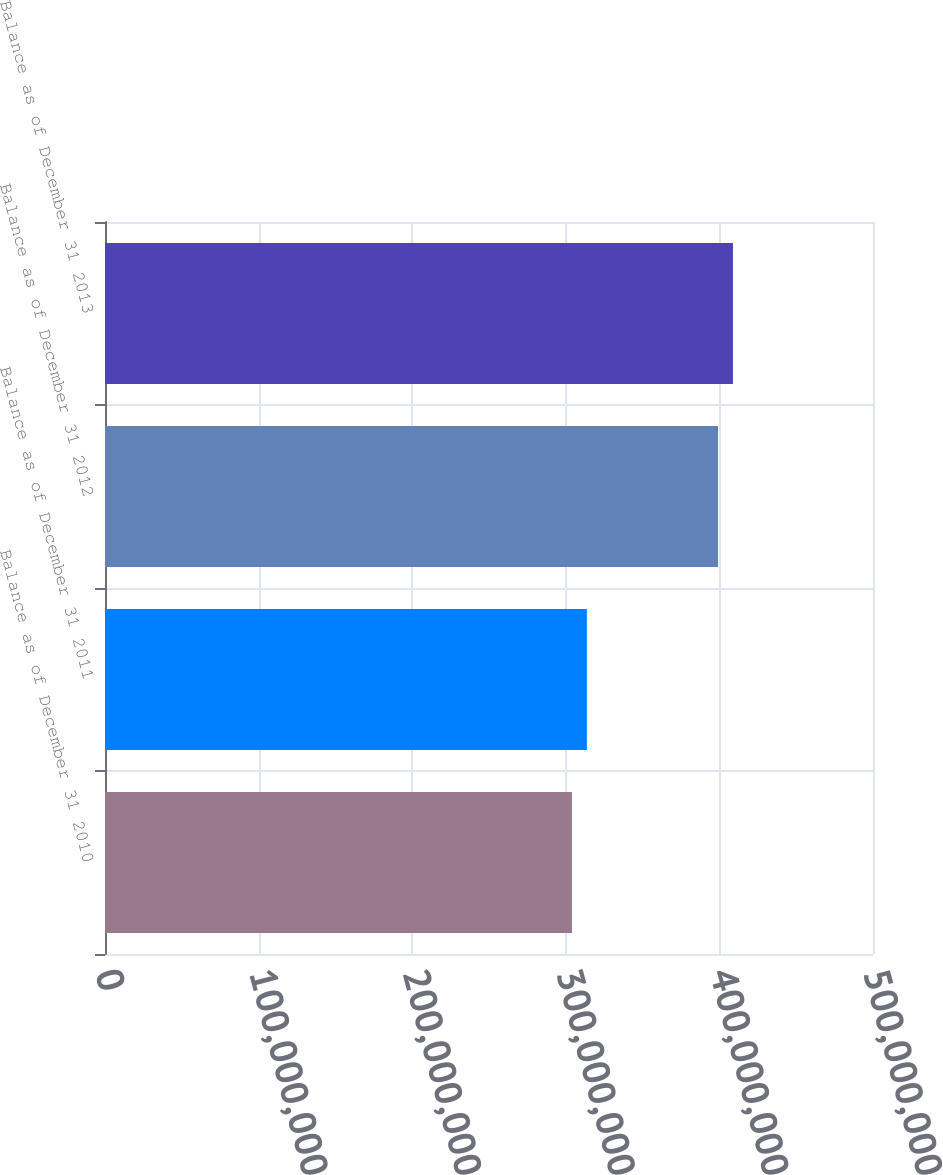<chart> <loc_0><loc_0><loc_500><loc_500><bar_chart><fcel>Balance as of December 31 2010<fcel>Balance as of December 31 2011<fcel>Balance as of December 31 2012<fcel>Balance as of December 31 2013<nl><fcel>3.04006e+08<fcel>3.13718e+08<fcel>3.99113e+08<fcel>4.08825e+08<nl></chart> 